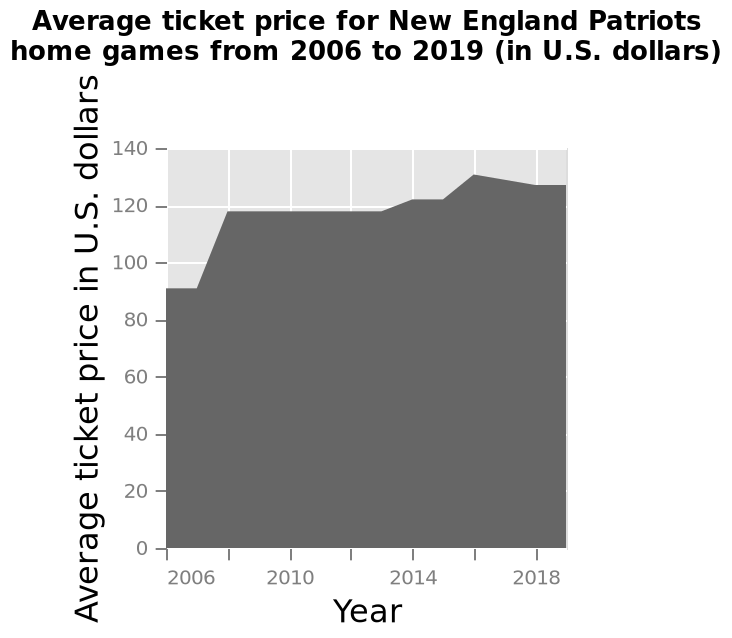<image>
What is being plotted on the y-axis of the area plot?  The y-axis plots the average ticket price for New England Patriots home games in U.S. dollars. In what currency are the average ticket prices represented on the area plot? The average ticket prices are represented in U.S. dollars. What was the pattern of ticket prices between 2007 and 2013? The pattern of ticket prices between 2007 and 2013 was that they remained stagnant. When did the sharpest increase in ticket prices occur?  The sharpest increase in ticket prices occurred between 2007 and 2008. please enumerates aspects of the construction of the chart Average ticket price for New England Patriots home games from 2006 to 2019 (in U.S. dollars) is a area plot. The y-axis plots Average ticket price in U.S. dollars with linear scale with a minimum of 0 and a maximum of 140 while the x-axis measures Year along linear scale of range 2006 to 2018. 